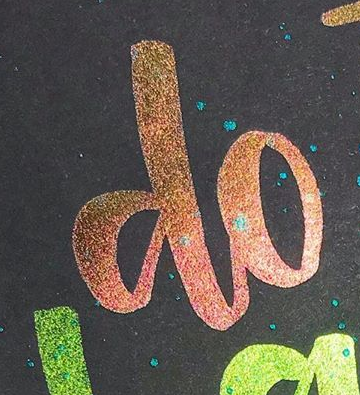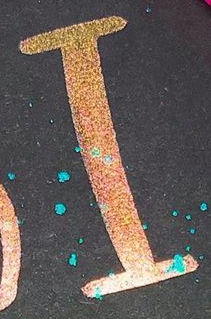Transcribe the words shown in these images in order, separated by a semicolon. do; I 